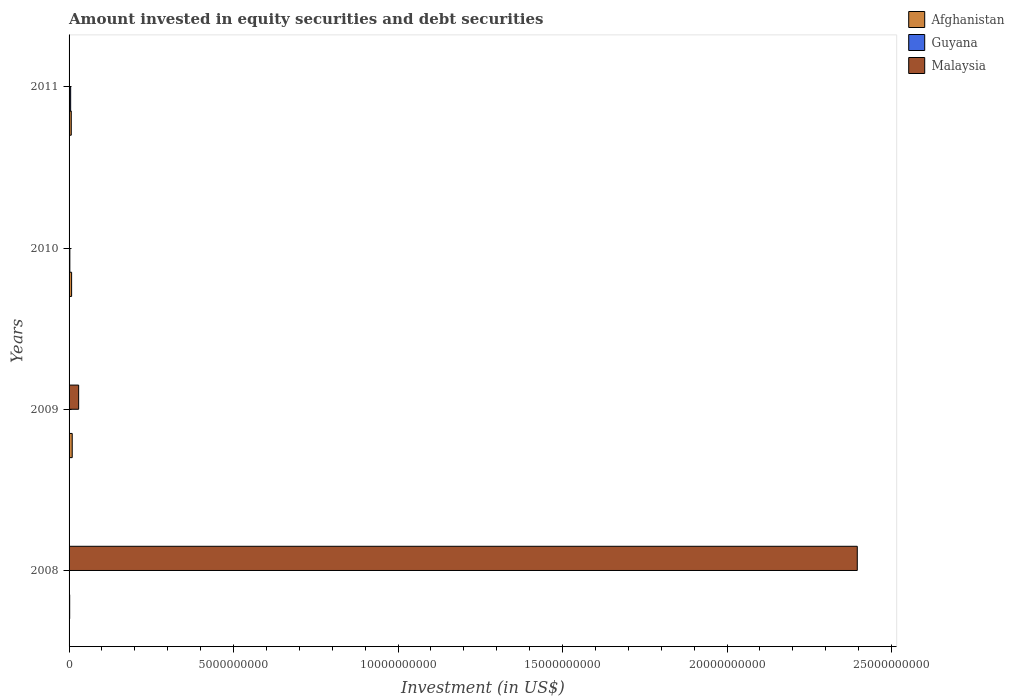How many different coloured bars are there?
Make the answer very short. 3. How many groups of bars are there?
Give a very brief answer. 4. Are the number of bars per tick equal to the number of legend labels?
Your response must be concise. No. What is the label of the 3rd group of bars from the top?
Your answer should be compact. 2009. What is the amount invested in equity securities and debt securities in Afghanistan in 2011?
Provide a succinct answer. 6.66e+07. Across all years, what is the maximum amount invested in equity securities and debt securities in Guyana?
Your answer should be compact. 4.83e+07. Across all years, what is the minimum amount invested in equity securities and debt securities in Afghanistan?
Your answer should be very brief. 1.86e+07. In which year was the amount invested in equity securities and debt securities in Guyana maximum?
Provide a succinct answer. 2011. What is the total amount invested in equity securities and debt securities in Malaysia in the graph?
Offer a very short reply. 2.43e+1. What is the difference between the amount invested in equity securities and debt securities in Afghanistan in 2009 and that in 2011?
Offer a very short reply. 2.89e+07. What is the difference between the amount invested in equity securities and debt securities in Afghanistan in 2010 and the amount invested in equity securities and debt securities in Guyana in 2009?
Provide a succinct answer. 7.73e+07. What is the average amount invested in equity securities and debt securities in Afghanistan per year?
Provide a succinct answer. 6.45e+07. In the year 2011, what is the difference between the amount invested in equity securities and debt securities in Guyana and amount invested in equity securities and debt securities in Afghanistan?
Keep it short and to the point. -1.83e+07. In how many years, is the amount invested in equity securities and debt securities in Malaysia greater than 24000000000 US$?
Offer a very short reply. 0. What is the ratio of the amount invested in equity securities and debt securities in Malaysia in 2008 to that in 2009?
Keep it short and to the point. 82.23. Is the difference between the amount invested in equity securities and debt securities in Guyana in 2010 and 2011 greater than the difference between the amount invested in equity securities and debt securities in Afghanistan in 2010 and 2011?
Your answer should be very brief. No. What is the difference between the highest and the second highest amount invested in equity securities and debt securities in Afghanistan?
Keep it short and to the point. 1.82e+07. What is the difference between the highest and the lowest amount invested in equity securities and debt securities in Afghanistan?
Offer a terse response. 7.69e+07. In how many years, is the amount invested in equity securities and debt securities in Guyana greater than the average amount invested in equity securities and debt securities in Guyana taken over all years?
Provide a succinct answer. 2. How many bars are there?
Ensure brevity in your answer.  8. Are all the bars in the graph horizontal?
Keep it short and to the point. Yes. How many years are there in the graph?
Offer a very short reply. 4. What is the difference between two consecutive major ticks on the X-axis?
Your response must be concise. 5.00e+09. Does the graph contain grids?
Give a very brief answer. No. Where does the legend appear in the graph?
Make the answer very short. Top right. How are the legend labels stacked?
Keep it short and to the point. Vertical. What is the title of the graph?
Your answer should be very brief. Amount invested in equity securities and debt securities. What is the label or title of the X-axis?
Make the answer very short. Investment (in US$). What is the label or title of the Y-axis?
Provide a succinct answer. Years. What is the Investment (in US$) of Afghanistan in 2008?
Offer a terse response. 1.86e+07. What is the Investment (in US$) in Malaysia in 2008?
Your answer should be compact. 2.40e+1. What is the Investment (in US$) in Afghanistan in 2009?
Your answer should be compact. 9.55e+07. What is the Investment (in US$) in Guyana in 2009?
Provide a short and direct response. 0. What is the Investment (in US$) of Malaysia in 2009?
Offer a terse response. 2.91e+08. What is the Investment (in US$) in Afghanistan in 2010?
Your answer should be compact. 7.73e+07. What is the Investment (in US$) of Guyana in 2010?
Ensure brevity in your answer.  2.35e+07. What is the Investment (in US$) of Afghanistan in 2011?
Your answer should be very brief. 6.66e+07. What is the Investment (in US$) in Guyana in 2011?
Your response must be concise. 4.83e+07. Across all years, what is the maximum Investment (in US$) of Afghanistan?
Make the answer very short. 9.55e+07. Across all years, what is the maximum Investment (in US$) of Guyana?
Offer a terse response. 4.83e+07. Across all years, what is the maximum Investment (in US$) in Malaysia?
Your response must be concise. 2.40e+1. Across all years, what is the minimum Investment (in US$) of Afghanistan?
Your answer should be very brief. 1.86e+07. What is the total Investment (in US$) in Afghanistan in the graph?
Make the answer very short. 2.58e+08. What is the total Investment (in US$) in Guyana in the graph?
Your answer should be compact. 7.18e+07. What is the total Investment (in US$) in Malaysia in the graph?
Offer a very short reply. 2.43e+1. What is the difference between the Investment (in US$) of Afghanistan in 2008 and that in 2009?
Make the answer very short. -7.69e+07. What is the difference between the Investment (in US$) in Malaysia in 2008 and that in 2009?
Your response must be concise. 2.37e+1. What is the difference between the Investment (in US$) in Afghanistan in 2008 and that in 2010?
Offer a very short reply. -5.88e+07. What is the difference between the Investment (in US$) of Afghanistan in 2008 and that in 2011?
Give a very brief answer. -4.80e+07. What is the difference between the Investment (in US$) of Afghanistan in 2009 and that in 2010?
Your answer should be very brief. 1.82e+07. What is the difference between the Investment (in US$) of Afghanistan in 2009 and that in 2011?
Provide a succinct answer. 2.89e+07. What is the difference between the Investment (in US$) of Afghanistan in 2010 and that in 2011?
Offer a very short reply. 1.07e+07. What is the difference between the Investment (in US$) in Guyana in 2010 and that in 2011?
Provide a short and direct response. -2.48e+07. What is the difference between the Investment (in US$) of Afghanistan in 2008 and the Investment (in US$) of Malaysia in 2009?
Ensure brevity in your answer.  -2.73e+08. What is the difference between the Investment (in US$) of Afghanistan in 2008 and the Investment (in US$) of Guyana in 2010?
Offer a terse response. -4.90e+06. What is the difference between the Investment (in US$) in Afghanistan in 2008 and the Investment (in US$) in Guyana in 2011?
Offer a terse response. -2.97e+07. What is the difference between the Investment (in US$) in Afghanistan in 2009 and the Investment (in US$) in Guyana in 2010?
Provide a succinct answer. 7.20e+07. What is the difference between the Investment (in US$) of Afghanistan in 2009 and the Investment (in US$) of Guyana in 2011?
Provide a short and direct response. 4.73e+07. What is the difference between the Investment (in US$) in Afghanistan in 2010 and the Investment (in US$) in Guyana in 2011?
Provide a short and direct response. 2.91e+07. What is the average Investment (in US$) in Afghanistan per year?
Make the answer very short. 6.45e+07. What is the average Investment (in US$) in Guyana per year?
Make the answer very short. 1.79e+07. What is the average Investment (in US$) in Malaysia per year?
Keep it short and to the point. 6.06e+09. In the year 2008, what is the difference between the Investment (in US$) of Afghanistan and Investment (in US$) of Malaysia?
Ensure brevity in your answer.  -2.39e+1. In the year 2009, what is the difference between the Investment (in US$) in Afghanistan and Investment (in US$) in Malaysia?
Your answer should be compact. -1.96e+08. In the year 2010, what is the difference between the Investment (in US$) in Afghanistan and Investment (in US$) in Guyana?
Make the answer very short. 5.39e+07. In the year 2011, what is the difference between the Investment (in US$) in Afghanistan and Investment (in US$) in Guyana?
Keep it short and to the point. 1.83e+07. What is the ratio of the Investment (in US$) in Afghanistan in 2008 to that in 2009?
Your response must be concise. 0.19. What is the ratio of the Investment (in US$) of Malaysia in 2008 to that in 2009?
Offer a terse response. 82.23. What is the ratio of the Investment (in US$) of Afghanistan in 2008 to that in 2010?
Offer a very short reply. 0.24. What is the ratio of the Investment (in US$) in Afghanistan in 2008 to that in 2011?
Ensure brevity in your answer.  0.28. What is the ratio of the Investment (in US$) in Afghanistan in 2009 to that in 2010?
Provide a succinct answer. 1.24. What is the ratio of the Investment (in US$) of Afghanistan in 2009 to that in 2011?
Offer a very short reply. 1.43. What is the ratio of the Investment (in US$) in Afghanistan in 2010 to that in 2011?
Give a very brief answer. 1.16. What is the ratio of the Investment (in US$) in Guyana in 2010 to that in 2011?
Your response must be concise. 0.49. What is the difference between the highest and the second highest Investment (in US$) of Afghanistan?
Make the answer very short. 1.82e+07. What is the difference between the highest and the lowest Investment (in US$) in Afghanistan?
Provide a short and direct response. 7.69e+07. What is the difference between the highest and the lowest Investment (in US$) in Guyana?
Offer a terse response. 4.83e+07. What is the difference between the highest and the lowest Investment (in US$) of Malaysia?
Offer a very short reply. 2.40e+1. 